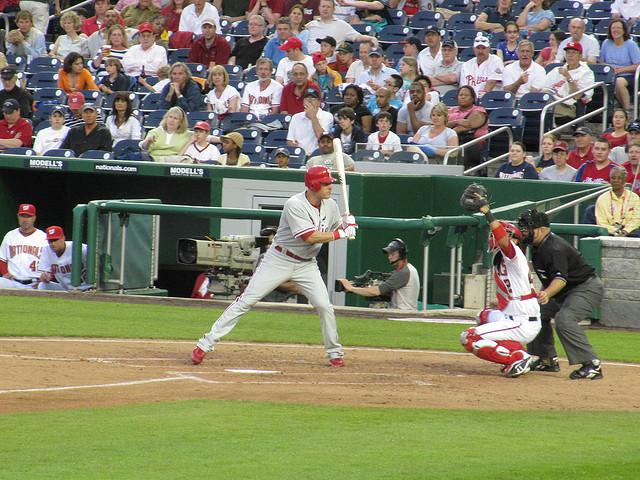Where is the ball?

Choices:
A) pitcher's hand
B) coach
C) batters glove
D) catcher's glove catcher's glove 